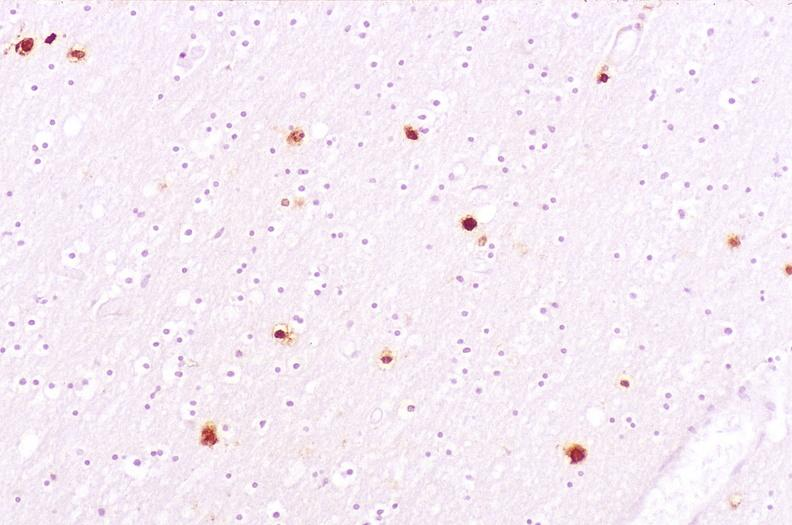what stain?
Answer the question using a single word or phrase. Immunoperoxidate 